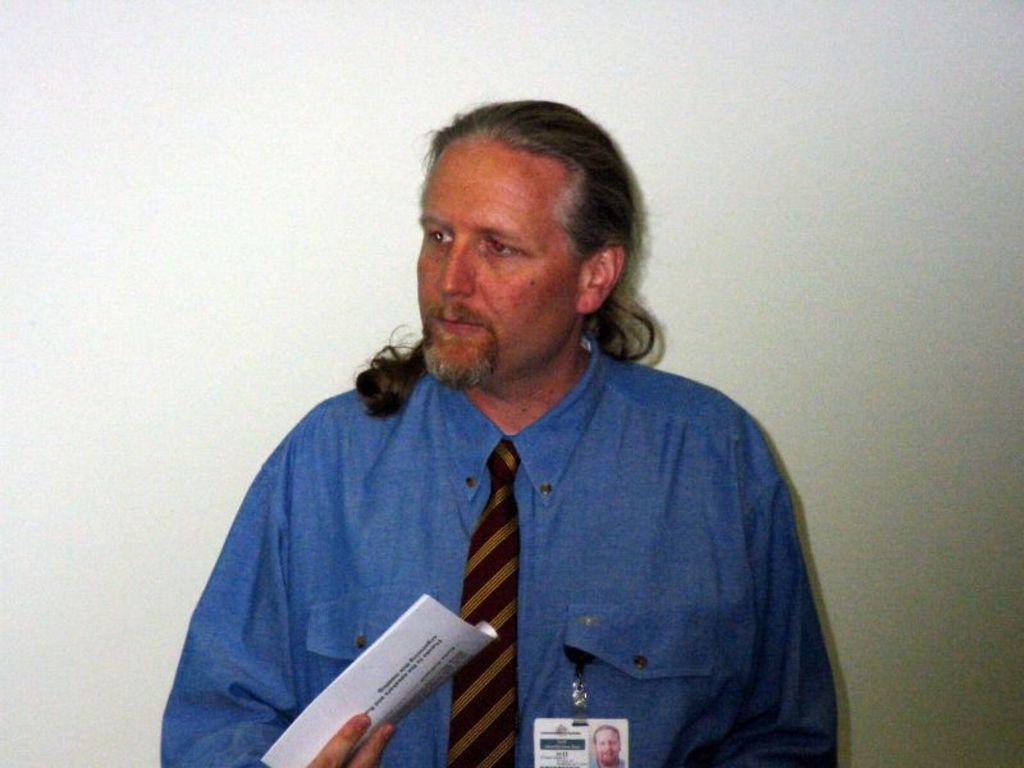In one or two sentences, can you explain what this image depicts? In this image I can see the person holding few papers and the person is wearing blue shirt and brown color tie and I can see the white color background. 